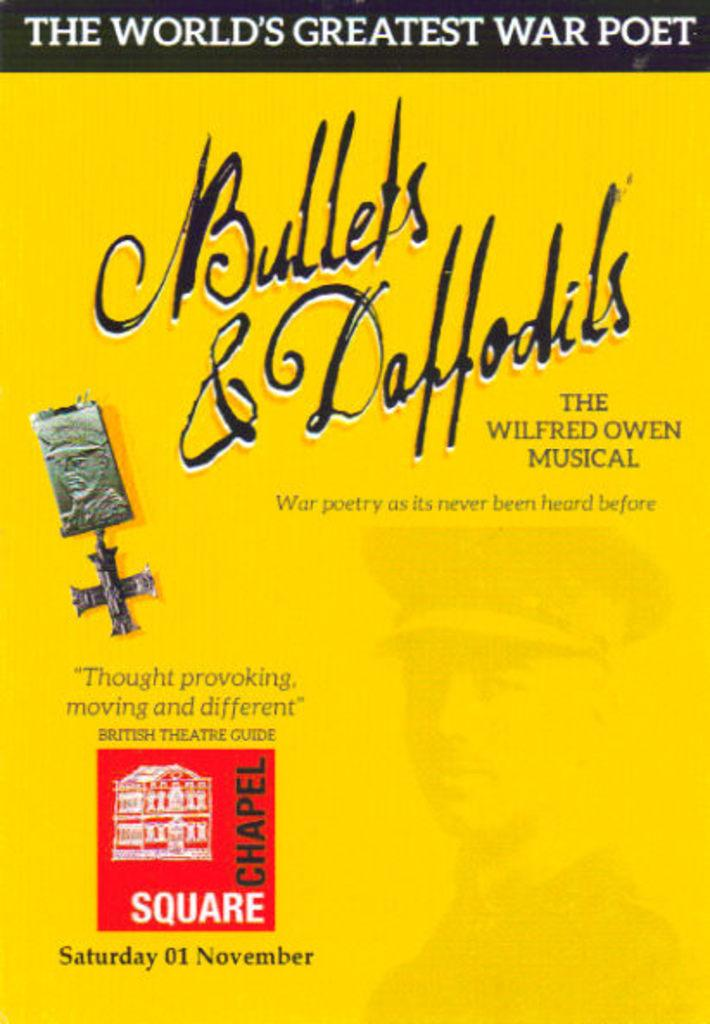<image>
Render a clear and concise summary of the photo. A poster advertises the world's greatest war poet and the Wilfrden Owen musical. 